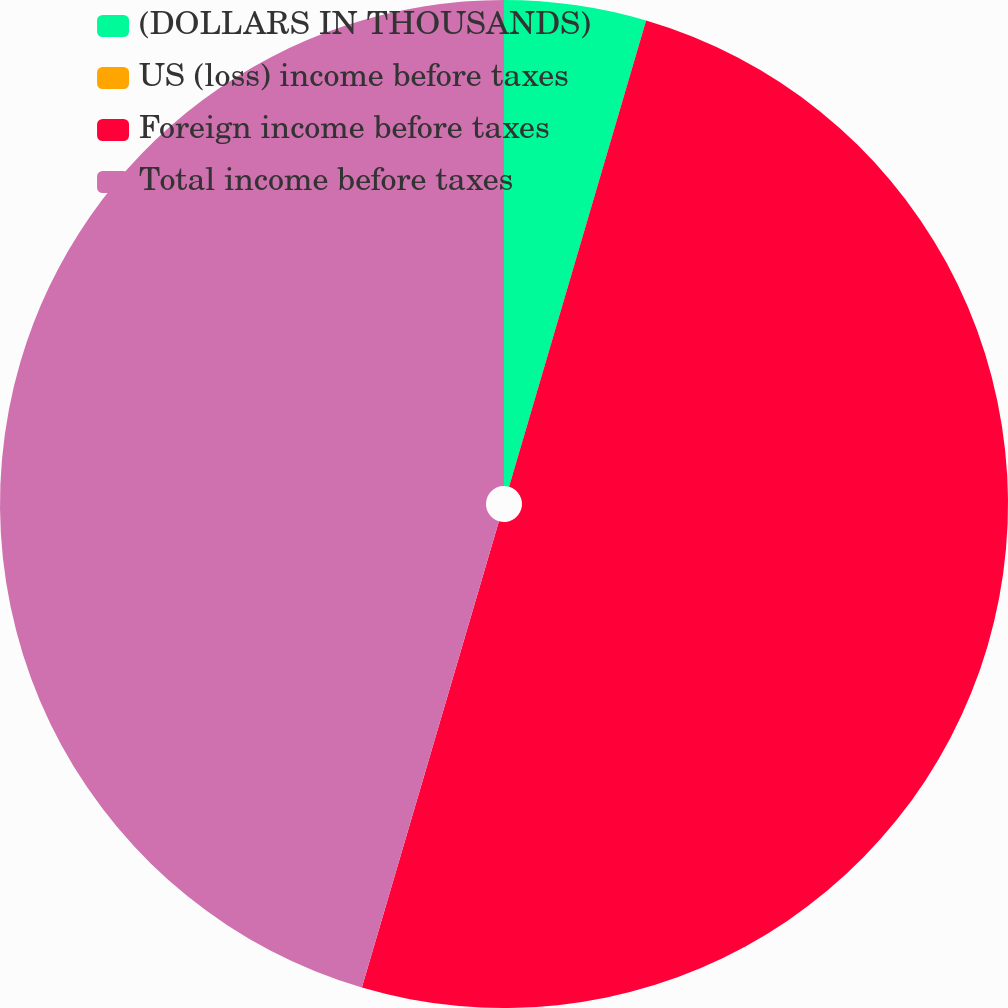<chart> <loc_0><loc_0><loc_500><loc_500><pie_chart><fcel>(DOLLARS IN THOUSANDS)<fcel>US (loss) income before taxes<fcel>Foreign income before taxes<fcel>Total income before taxes<nl><fcel>4.55%<fcel>0.0%<fcel>50.0%<fcel>45.45%<nl></chart> 